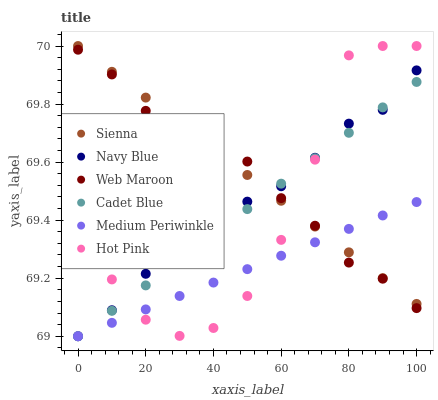Does Medium Periwinkle have the minimum area under the curve?
Answer yes or no. Yes. Does Sienna have the maximum area under the curve?
Answer yes or no. Yes. Does Navy Blue have the minimum area under the curve?
Answer yes or no. No. Does Navy Blue have the maximum area under the curve?
Answer yes or no. No. Is Sienna the smoothest?
Answer yes or no. Yes. Is Hot Pink the roughest?
Answer yes or no. Yes. Is Medium Periwinkle the smoothest?
Answer yes or no. No. Is Medium Periwinkle the roughest?
Answer yes or no. No. Does Cadet Blue have the lowest value?
Answer yes or no. Yes. Does Hot Pink have the lowest value?
Answer yes or no. No. Does Sienna have the highest value?
Answer yes or no. Yes. Does Navy Blue have the highest value?
Answer yes or no. No. Does Medium Periwinkle intersect Navy Blue?
Answer yes or no. Yes. Is Medium Periwinkle less than Navy Blue?
Answer yes or no. No. Is Medium Periwinkle greater than Navy Blue?
Answer yes or no. No. 